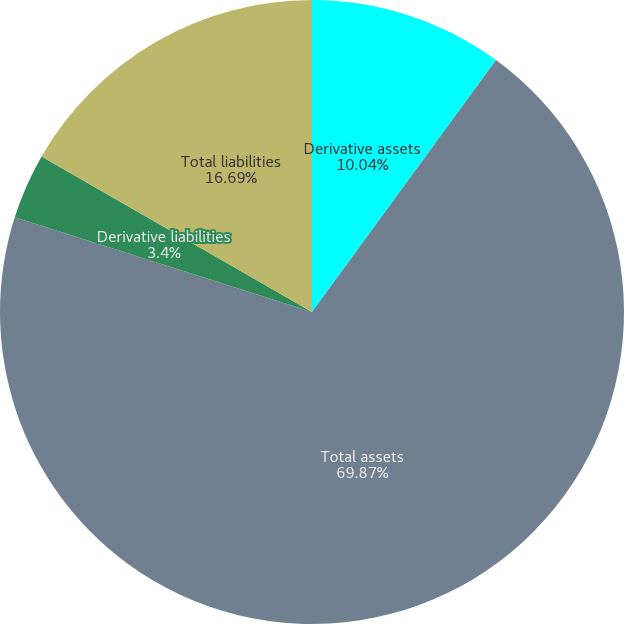<chart> <loc_0><loc_0><loc_500><loc_500><pie_chart><fcel>Derivative assets<fcel>Total assets<fcel>Derivative liabilities<fcel>Total liabilities<nl><fcel>10.04%<fcel>69.87%<fcel>3.4%<fcel>16.69%<nl></chart> 